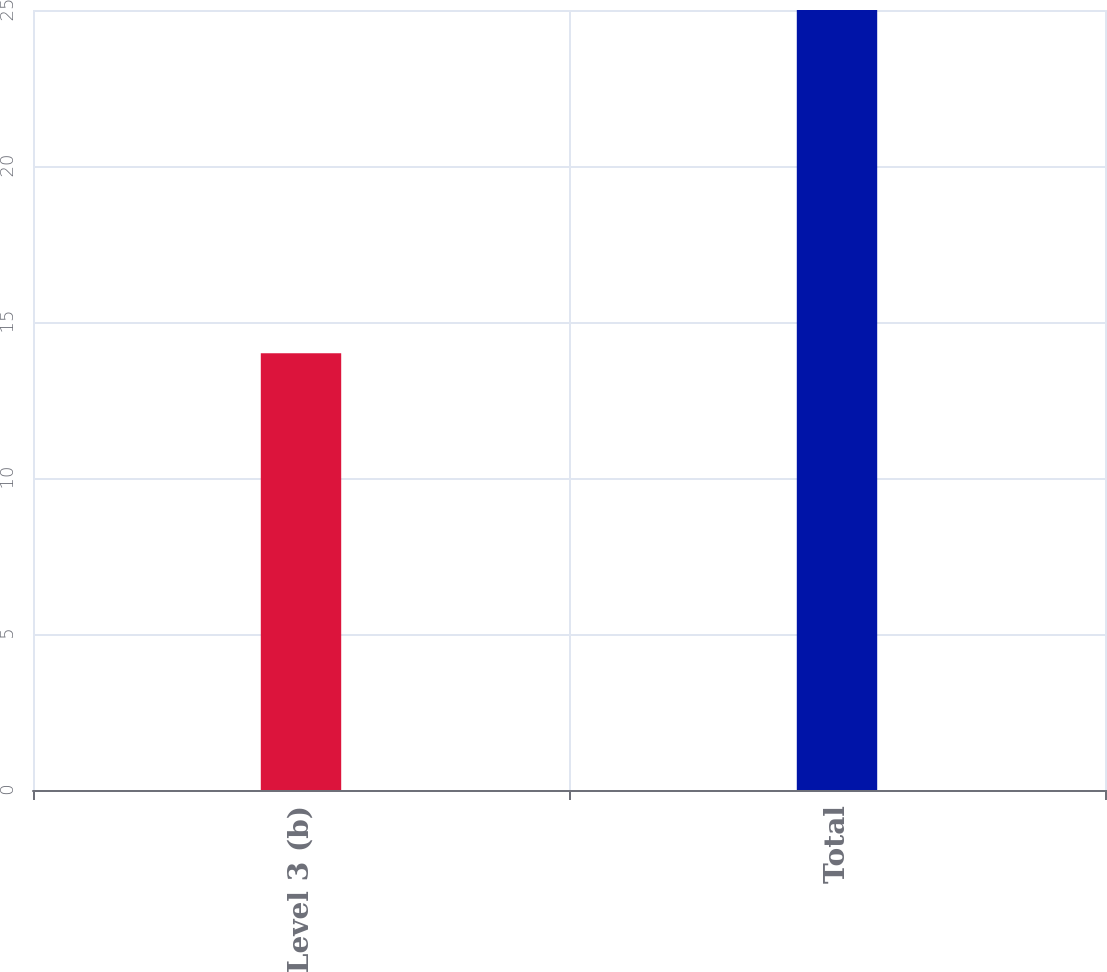Convert chart. <chart><loc_0><loc_0><loc_500><loc_500><bar_chart><fcel>Level 3 (b)<fcel>Total<nl><fcel>14<fcel>25<nl></chart> 